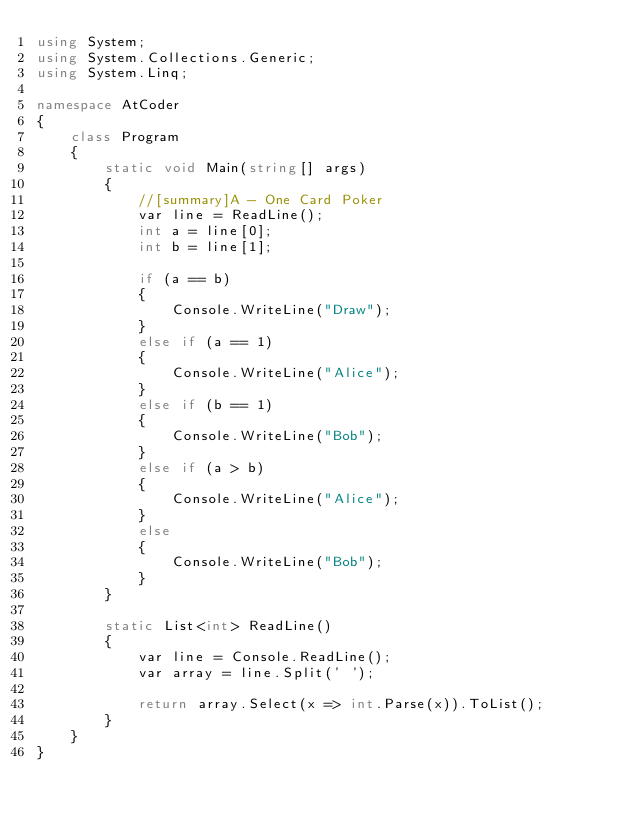<code> <loc_0><loc_0><loc_500><loc_500><_C#_>using System;
using System.Collections.Generic;
using System.Linq;

namespace AtCoder
{
    class Program
    {
        static void Main(string[] args)
        {
            //[summary]A - One Card Poker
            var line = ReadLine();
            int a = line[0];
            int b = line[1];

            if (a == b)
            {
                Console.WriteLine("Draw");
            }
            else if (a == 1)
            {
                Console.WriteLine("Alice");
            }
            else if (b == 1)
            {
                Console.WriteLine("Bob");
            }
            else if (a > b)
            {
                Console.WriteLine("Alice");
            }
            else
            {
                Console.WriteLine("Bob");
            }
        }

        static List<int> ReadLine()
        {
            var line = Console.ReadLine();
            var array = line.Split(' ');

            return array.Select(x => int.Parse(x)).ToList();
        }
    }
}</code> 